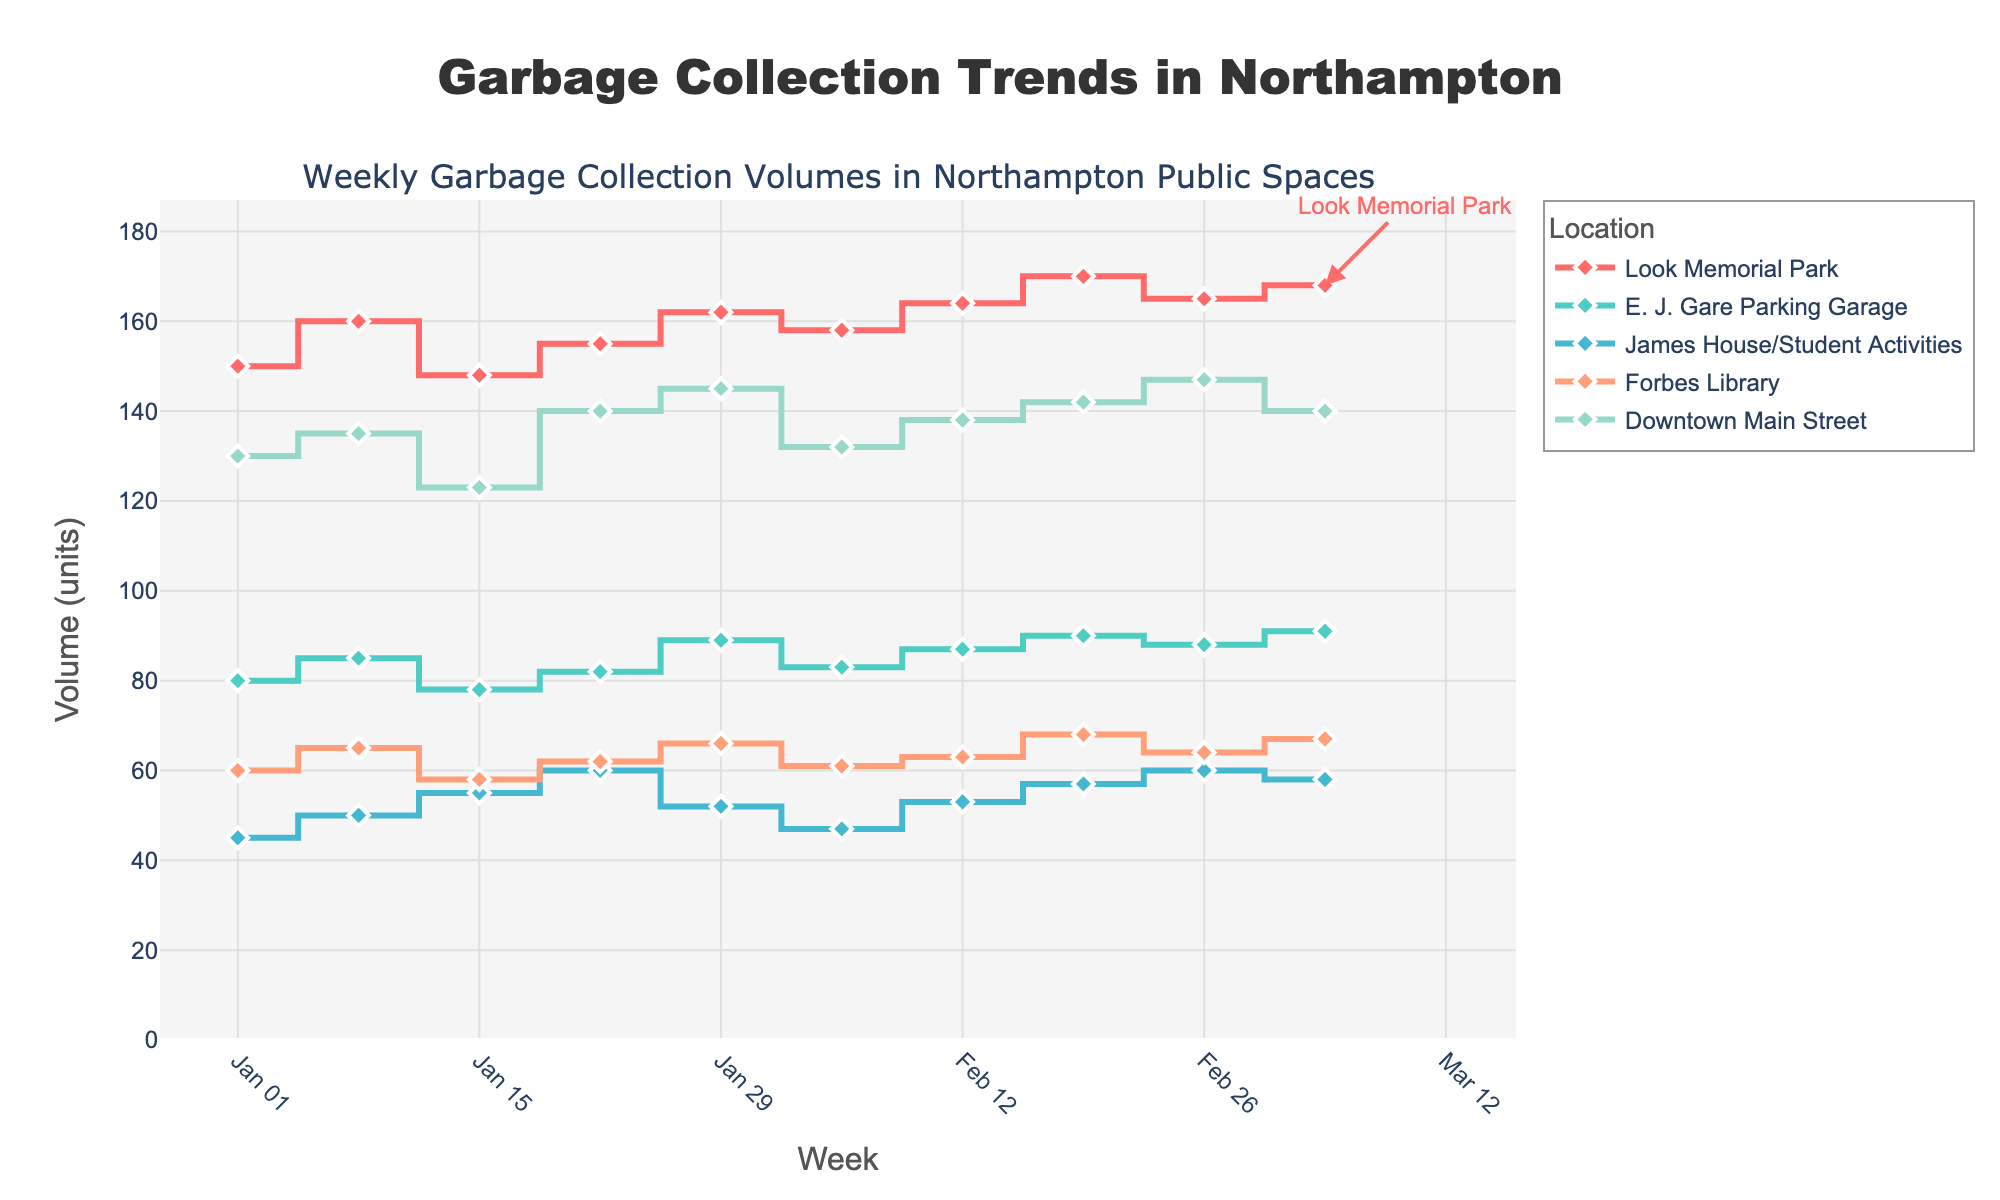What is the title of the figure? The title of the figure is displayed at the top center of the plot.
Answer: Garbage Collection Trends in Northampton Which location has the highest garbage collection volume in the week ending on March 5, 2023? Look at the data points for all locations on the March 5, 2023, tick on the x-axis and compare the y-axis values.
Answer: Look Memorial Park How many locations are being tracked in the figure? Count the number of different color traces (lines/markers) representing different locations.
Answer: Five What is the unit for the y-axis? The y-axis title indicates the measurement unit used for the garbage collection volume.
Answer: Volume (units) Which location shows the steepest increase in garbage collection volume between January 29, 2023, and February 5, 2023? Compare the vertical distance between data points of January 29 and February 5 for all locations; the location with the largest difference has the steepest increase.
Answer: E. J. Gare Parking Garage How does the garbage collection volume for Look Memorial Park compare between January 1, 2023, and January 29, 2023? Look at the y-axis values for Look Memorial Park on January 1 and January 29 and calculate the difference. 162 - 150 = 12
Answer: It increased by 12 units What is the average garbage collection volume for Downtown Main Street over the displayed period? Add the garbage volumes for Downtown Main Street for each week and divide by the number of weeks. (130 + 135 + 123 + 140 + 145 + 132 + 138 + 142 + 147 + 140) / 10 = 1332 / 10 = 133.2
Answer: 133.2 units Which location had the least variation in garbage collection volumes throughout the displayed period? Determine which location has the smallest range (difference between max and min values).
Answer: James House/Student Activities What is the range of garbage collection volumes for Forbes Library during the displayed period? Subtract the minimum volume for Forbes Library from the maximum volume observed in the period. Max = 68, Min = 58, so Range = 68 - 58 = 10
Answer: 10 units Which week saw the highest overall garbage collection volume across all locations? Sum the weekly volumes for all locations and find the week with the highest sum. For the week with the highest sum: (Look Memorial 170 + E. J. Gare 90 + James House 57 + Forbes Library 68 + Downtown 142) = 527 on February 19, 2023
Answer: Week of February 19, 2023 